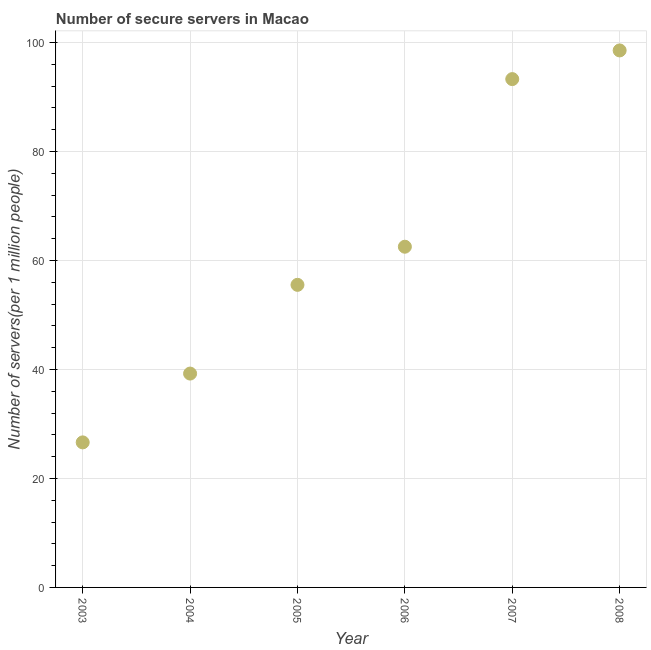What is the number of secure internet servers in 2005?
Ensure brevity in your answer.  55.54. Across all years, what is the maximum number of secure internet servers?
Offer a very short reply. 98.57. Across all years, what is the minimum number of secure internet servers?
Make the answer very short. 26.62. In which year was the number of secure internet servers maximum?
Your answer should be very brief. 2008. In which year was the number of secure internet servers minimum?
Your answer should be very brief. 2003. What is the sum of the number of secure internet servers?
Make the answer very short. 375.82. What is the difference between the number of secure internet servers in 2003 and 2004?
Your answer should be very brief. -12.63. What is the average number of secure internet servers per year?
Provide a short and direct response. 62.64. What is the median number of secure internet servers?
Provide a succinct answer. 59.04. What is the ratio of the number of secure internet servers in 2004 to that in 2008?
Ensure brevity in your answer.  0.4. Is the number of secure internet servers in 2003 less than that in 2007?
Keep it short and to the point. Yes. Is the difference between the number of secure internet servers in 2006 and 2007 greater than the difference between any two years?
Your answer should be very brief. No. What is the difference between the highest and the second highest number of secure internet servers?
Your response must be concise. 5.26. What is the difference between the highest and the lowest number of secure internet servers?
Offer a terse response. 71.94. How many dotlines are there?
Keep it short and to the point. 1. How many years are there in the graph?
Keep it short and to the point. 6. What is the difference between two consecutive major ticks on the Y-axis?
Offer a very short reply. 20. What is the title of the graph?
Provide a short and direct response. Number of secure servers in Macao. What is the label or title of the X-axis?
Make the answer very short. Year. What is the label or title of the Y-axis?
Ensure brevity in your answer.  Number of servers(per 1 million people). What is the Number of servers(per 1 million people) in 2003?
Your answer should be compact. 26.62. What is the Number of servers(per 1 million people) in 2004?
Keep it short and to the point. 39.25. What is the Number of servers(per 1 million people) in 2005?
Your answer should be compact. 55.54. What is the Number of servers(per 1 million people) in 2006?
Provide a succinct answer. 62.54. What is the Number of servers(per 1 million people) in 2007?
Your answer should be compact. 93.3. What is the Number of servers(per 1 million people) in 2008?
Keep it short and to the point. 98.57. What is the difference between the Number of servers(per 1 million people) in 2003 and 2004?
Offer a terse response. -12.63. What is the difference between the Number of servers(per 1 million people) in 2003 and 2005?
Offer a terse response. -28.92. What is the difference between the Number of servers(per 1 million people) in 2003 and 2006?
Ensure brevity in your answer.  -35.91. What is the difference between the Number of servers(per 1 million people) in 2003 and 2007?
Your response must be concise. -66.68. What is the difference between the Number of servers(per 1 million people) in 2003 and 2008?
Offer a terse response. -71.94. What is the difference between the Number of servers(per 1 million people) in 2004 and 2005?
Make the answer very short. -16.29. What is the difference between the Number of servers(per 1 million people) in 2004 and 2006?
Your answer should be compact. -23.28. What is the difference between the Number of servers(per 1 million people) in 2004 and 2007?
Make the answer very short. -54.05. What is the difference between the Number of servers(per 1 million people) in 2004 and 2008?
Ensure brevity in your answer.  -59.31. What is the difference between the Number of servers(per 1 million people) in 2005 and 2006?
Your answer should be compact. -7. What is the difference between the Number of servers(per 1 million people) in 2005 and 2007?
Keep it short and to the point. -37.76. What is the difference between the Number of servers(per 1 million people) in 2005 and 2008?
Keep it short and to the point. -43.03. What is the difference between the Number of servers(per 1 million people) in 2006 and 2007?
Your answer should be very brief. -30.77. What is the difference between the Number of servers(per 1 million people) in 2006 and 2008?
Offer a very short reply. -36.03. What is the difference between the Number of servers(per 1 million people) in 2007 and 2008?
Provide a succinct answer. -5.26. What is the ratio of the Number of servers(per 1 million people) in 2003 to that in 2004?
Offer a terse response. 0.68. What is the ratio of the Number of servers(per 1 million people) in 2003 to that in 2005?
Ensure brevity in your answer.  0.48. What is the ratio of the Number of servers(per 1 million people) in 2003 to that in 2006?
Ensure brevity in your answer.  0.43. What is the ratio of the Number of servers(per 1 million people) in 2003 to that in 2007?
Ensure brevity in your answer.  0.28. What is the ratio of the Number of servers(per 1 million people) in 2003 to that in 2008?
Your answer should be very brief. 0.27. What is the ratio of the Number of servers(per 1 million people) in 2004 to that in 2005?
Offer a very short reply. 0.71. What is the ratio of the Number of servers(per 1 million people) in 2004 to that in 2006?
Your response must be concise. 0.63. What is the ratio of the Number of servers(per 1 million people) in 2004 to that in 2007?
Provide a short and direct response. 0.42. What is the ratio of the Number of servers(per 1 million people) in 2004 to that in 2008?
Make the answer very short. 0.4. What is the ratio of the Number of servers(per 1 million people) in 2005 to that in 2006?
Your response must be concise. 0.89. What is the ratio of the Number of servers(per 1 million people) in 2005 to that in 2007?
Offer a terse response. 0.59. What is the ratio of the Number of servers(per 1 million people) in 2005 to that in 2008?
Give a very brief answer. 0.56. What is the ratio of the Number of servers(per 1 million people) in 2006 to that in 2007?
Your response must be concise. 0.67. What is the ratio of the Number of servers(per 1 million people) in 2006 to that in 2008?
Offer a terse response. 0.63. What is the ratio of the Number of servers(per 1 million people) in 2007 to that in 2008?
Offer a terse response. 0.95. 